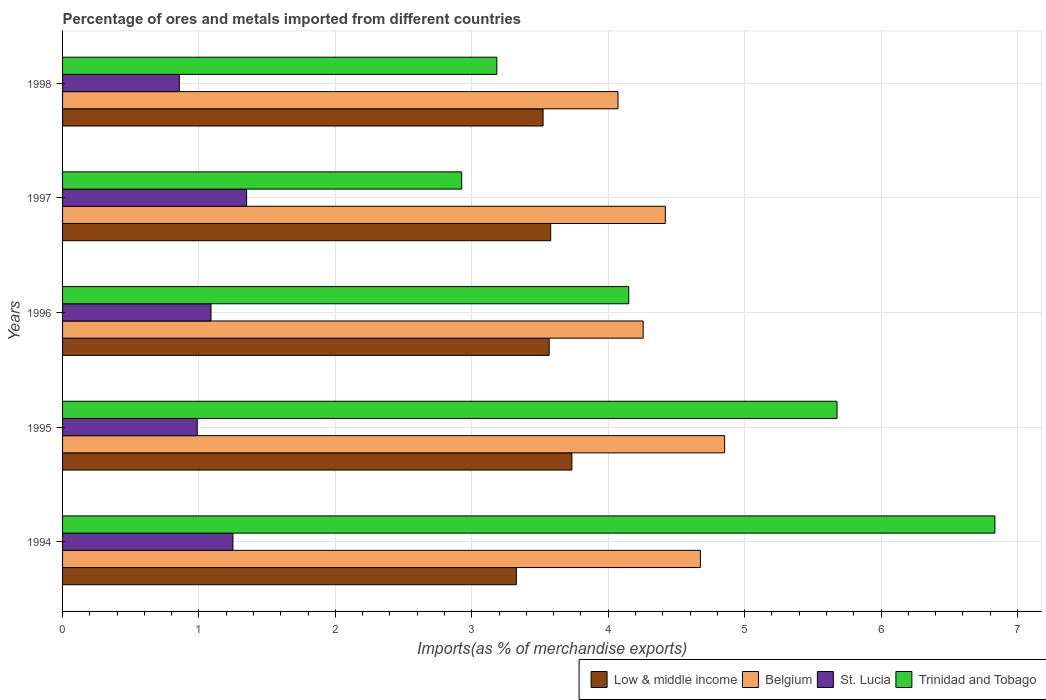How many groups of bars are there?
Your answer should be compact. 5. Are the number of bars per tick equal to the number of legend labels?
Offer a very short reply. Yes. Are the number of bars on each tick of the Y-axis equal?
Provide a succinct answer. Yes. What is the label of the 2nd group of bars from the top?
Your response must be concise. 1997. What is the percentage of imports to different countries in Trinidad and Tobago in 1996?
Your answer should be very brief. 4.15. Across all years, what is the maximum percentage of imports to different countries in Belgium?
Your answer should be very brief. 4.85. Across all years, what is the minimum percentage of imports to different countries in St. Lucia?
Your answer should be very brief. 0.86. In which year was the percentage of imports to different countries in Trinidad and Tobago maximum?
Give a very brief answer. 1994. What is the total percentage of imports to different countries in Belgium in the graph?
Keep it short and to the point. 22.28. What is the difference between the percentage of imports to different countries in Trinidad and Tobago in 1996 and that in 1997?
Your answer should be very brief. 1.22. What is the difference between the percentage of imports to different countries in Trinidad and Tobago in 1994 and the percentage of imports to different countries in St. Lucia in 1998?
Offer a very short reply. 5.98. What is the average percentage of imports to different countries in St. Lucia per year?
Your response must be concise. 1.11. In the year 1996, what is the difference between the percentage of imports to different countries in Low & middle income and percentage of imports to different countries in Belgium?
Your answer should be very brief. -0.69. In how many years, is the percentage of imports to different countries in St. Lucia greater than 1.8 %?
Make the answer very short. 0. What is the ratio of the percentage of imports to different countries in Low & middle income in 1996 to that in 1998?
Make the answer very short. 1.01. Is the percentage of imports to different countries in Belgium in 1996 less than that in 1998?
Give a very brief answer. No. Is the difference between the percentage of imports to different countries in Low & middle income in 1994 and 1996 greater than the difference between the percentage of imports to different countries in Belgium in 1994 and 1996?
Ensure brevity in your answer.  No. What is the difference between the highest and the second highest percentage of imports to different countries in Trinidad and Tobago?
Offer a terse response. 1.16. What is the difference between the highest and the lowest percentage of imports to different countries in Trinidad and Tobago?
Your response must be concise. 3.91. Is it the case that in every year, the sum of the percentage of imports to different countries in Trinidad and Tobago and percentage of imports to different countries in Low & middle income is greater than the sum of percentage of imports to different countries in Belgium and percentage of imports to different countries in St. Lucia?
Make the answer very short. No. What does the 4th bar from the top in 1997 represents?
Provide a short and direct response. Low & middle income. What does the 2nd bar from the bottom in 1995 represents?
Your answer should be compact. Belgium. How many bars are there?
Your response must be concise. 20. How many years are there in the graph?
Offer a terse response. 5. What is the difference between two consecutive major ticks on the X-axis?
Your response must be concise. 1. Are the values on the major ticks of X-axis written in scientific E-notation?
Give a very brief answer. No. Does the graph contain grids?
Offer a very short reply. Yes. Where does the legend appear in the graph?
Your answer should be very brief. Bottom right. How are the legend labels stacked?
Your response must be concise. Horizontal. What is the title of the graph?
Provide a succinct answer. Percentage of ores and metals imported from different countries. What is the label or title of the X-axis?
Provide a short and direct response. Imports(as % of merchandise exports). What is the Imports(as % of merchandise exports) in Low & middle income in 1994?
Ensure brevity in your answer.  3.33. What is the Imports(as % of merchandise exports) in Belgium in 1994?
Your response must be concise. 4.68. What is the Imports(as % of merchandise exports) in St. Lucia in 1994?
Provide a succinct answer. 1.25. What is the Imports(as % of merchandise exports) of Trinidad and Tobago in 1994?
Provide a succinct answer. 6.83. What is the Imports(as % of merchandise exports) in Low & middle income in 1995?
Give a very brief answer. 3.73. What is the Imports(as % of merchandise exports) of Belgium in 1995?
Keep it short and to the point. 4.85. What is the Imports(as % of merchandise exports) of St. Lucia in 1995?
Ensure brevity in your answer.  0.99. What is the Imports(as % of merchandise exports) in Trinidad and Tobago in 1995?
Provide a succinct answer. 5.68. What is the Imports(as % of merchandise exports) in Low & middle income in 1996?
Make the answer very short. 3.57. What is the Imports(as % of merchandise exports) of Belgium in 1996?
Provide a short and direct response. 4.26. What is the Imports(as % of merchandise exports) in St. Lucia in 1996?
Provide a short and direct response. 1.09. What is the Imports(as % of merchandise exports) of Trinidad and Tobago in 1996?
Give a very brief answer. 4.15. What is the Imports(as % of merchandise exports) in Low & middle income in 1997?
Provide a short and direct response. 3.58. What is the Imports(as % of merchandise exports) in Belgium in 1997?
Provide a short and direct response. 4.42. What is the Imports(as % of merchandise exports) of St. Lucia in 1997?
Your answer should be compact. 1.35. What is the Imports(as % of merchandise exports) in Trinidad and Tobago in 1997?
Provide a succinct answer. 2.93. What is the Imports(as % of merchandise exports) of Low & middle income in 1998?
Offer a very short reply. 3.52. What is the Imports(as % of merchandise exports) in Belgium in 1998?
Keep it short and to the point. 4.07. What is the Imports(as % of merchandise exports) of St. Lucia in 1998?
Your answer should be very brief. 0.86. What is the Imports(as % of merchandise exports) in Trinidad and Tobago in 1998?
Provide a succinct answer. 3.18. Across all years, what is the maximum Imports(as % of merchandise exports) of Low & middle income?
Your answer should be compact. 3.73. Across all years, what is the maximum Imports(as % of merchandise exports) in Belgium?
Provide a short and direct response. 4.85. Across all years, what is the maximum Imports(as % of merchandise exports) of St. Lucia?
Keep it short and to the point. 1.35. Across all years, what is the maximum Imports(as % of merchandise exports) in Trinidad and Tobago?
Offer a very short reply. 6.83. Across all years, what is the minimum Imports(as % of merchandise exports) of Low & middle income?
Make the answer very short. 3.33. Across all years, what is the minimum Imports(as % of merchandise exports) in Belgium?
Your response must be concise. 4.07. Across all years, what is the minimum Imports(as % of merchandise exports) in St. Lucia?
Give a very brief answer. 0.86. Across all years, what is the minimum Imports(as % of merchandise exports) of Trinidad and Tobago?
Your answer should be very brief. 2.93. What is the total Imports(as % of merchandise exports) of Low & middle income in the graph?
Offer a terse response. 17.73. What is the total Imports(as % of merchandise exports) in Belgium in the graph?
Provide a succinct answer. 22.28. What is the total Imports(as % of merchandise exports) in St. Lucia in the graph?
Give a very brief answer. 5.53. What is the total Imports(as % of merchandise exports) in Trinidad and Tobago in the graph?
Provide a succinct answer. 22.77. What is the difference between the Imports(as % of merchandise exports) of Low & middle income in 1994 and that in 1995?
Provide a succinct answer. -0.41. What is the difference between the Imports(as % of merchandise exports) in Belgium in 1994 and that in 1995?
Ensure brevity in your answer.  -0.18. What is the difference between the Imports(as % of merchandise exports) in St. Lucia in 1994 and that in 1995?
Your answer should be compact. 0.26. What is the difference between the Imports(as % of merchandise exports) of Trinidad and Tobago in 1994 and that in 1995?
Your answer should be compact. 1.16. What is the difference between the Imports(as % of merchandise exports) of Low & middle income in 1994 and that in 1996?
Your answer should be compact. -0.24. What is the difference between the Imports(as % of merchandise exports) of Belgium in 1994 and that in 1996?
Your response must be concise. 0.42. What is the difference between the Imports(as % of merchandise exports) of St. Lucia in 1994 and that in 1996?
Make the answer very short. 0.16. What is the difference between the Imports(as % of merchandise exports) of Trinidad and Tobago in 1994 and that in 1996?
Provide a succinct answer. 2.68. What is the difference between the Imports(as % of merchandise exports) of Low & middle income in 1994 and that in 1997?
Make the answer very short. -0.25. What is the difference between the Imports(as % of merchandise exports) in Belgium in 1994 and that in 1997?
Offer a terse response. 0.26. What is the difference between the Imports(as % of merchandise exports) in St. Lucia in 1994 and that in 1997?
Ensure brevity in your answer.  -0.1. What is the difference between the Imports(as % of merchandise exports) in Trinidad and Tobago in 1994 and that in 1997?
Make the answer very short. 3.91. What is the difference between the Imports(as % of merchandise exports) in Low & middle income in 1994 and that in 1998?
Your answer should be compact. -0.2. What is the difference between the Imports(as % of merchandise exports) of Belgium in 1994 and that in 1998?
Offer a terse response. 0.6. What is the difference between the Imports(as % of merchandise exports) in St. Lucia in 1994 and that in 1998?
Offer a very short reply. 0.39. What is the difference between the Imports(as % of merchandise exports) of Trinidad and Tobago in 1994 and that in 1998?
Your answer should be very brief. 3.65. What is the difference between the Imports(as % of merchandise exports) of Low & middle income in 1995 and that in 1996?
Offer a terse response. 0.17. What is the difference between the Imports(as % of merchandise exports) in Belgium in 1995 and that in 1996?
Provide a succinct answer. 0.6. What is the difference between the Imports(as % of merchandise exports) in St. Lucia in 1995 and that in 1996?
Give a very brief answer. -0.1. What is the difference between the Imports(as % of merchandise exports) of Trinidad and Tobago in 1995 and that in 1996?
Provide a succinct answer. 1.53. What is the difference between the Imports(as % of merchandise exports) of Low & middle income in 1995 and that in 1997?
Your answer should be compact. 0.16. What is the difference between the Imports(as % of merchandise exports) of Belgium in 1995 and that in 1997?
Provide a succinct answer. 0.43. What is the difference between the Imports(as % of merchandise exports) of St. Lucia in 1995 and that in 1997?
Make the answer very short. -0.36. What is the difference between the Imports(as % of merchandise exports) in Trinidad and Tobago in 1995 and that in 1997?
Ensure brevity in your answer.  2.75. What is the difference between the Imports(as % of merchandise exports) in Low & middle income in 1995 and that in 1998?
Provide a succinct answer. 0.21. What is the difference between the Imports(as % of merchandise exports) in Belgium in 1995 and that in 1998?
Offer a very short reply. 0.78. What is the difference between the Imports(as % of merchandise exports) of St. Lucia in 1995 and that in 1998?
Make the answer very short. 0.13. What is the difference between the Imports(as % of merchandise exports) of Trinidad and Tobago in 1995 and that in 1998?
Offer a very short reply. 2.49. What is the difference between the Imports(as % of merchandise exports) in Low & middle income in 1996 and that in 1997?
Keep it short and to the point. -0.01. What is the difference between the Imports(as % of merchandise exports) of Belgium in 1996 and that in 1997?
Offer a terse response. -0.16. What is the difference between the Imports(as % of merchandise exports) in St. Lucia in 1996 and that in 1997?
Your response must be concise. -0.26. What is the difference between the Imports(as % of merchandise exports) in Trinidad and Tobago in 1996 and that in 1997?
Give a very brief answer. 1.22. What is the difference between the Imports(as % of merchandise exports) of Low & middle income in 1996 and that in 1998?
Make the answer very short. 0.04. What is the difference between the Imports(as % of merchandise exports) of Belgium in 1996 and that in 1998?
Make the answer very short. 0.18. What is the difference between the Imports(as % of merchandise exports) in St. Lucia in 1996 and that in 1998?
Give a very brief answer. 0.23. What is the difference between the Imports(as % of merchandise exports) in Low & middle income in 1997 and that in 1998?
Provide a succinct answer. 0.06. What is the difference between the Imports(as % of merchandise exports) of Belgium in 1997 and that in 1998?
Give a very brief answer. 0.35. What is the difference between the Imports(as % of merchandise exports) of St. Lucia in 1997 and that in 1998?
Offer a terse response. 0.49. What is the difference between the Imports(as % of merchandise exports) in Trinidad and Tobago in 1997 and that in 1998?
Give a very brief answer. -0.26. What is the difference between the Imports(as % of merchandise exports) of Low & middle income in 1994 and the Imports(as % of merchandise exports) of Belgium in 1995?
Provide a short and direct response. -1.53. What is the difference between the Imports(as % of merchandise exports) in Low & middle income in 1994 and the Imports(as % of merchandise exports) in St. Lucia in 1995?
Give a very brief answer. 2.34. What is the difference between the Imports(as % of merchandise exports) in Low & middle income in 1994 and the Imports(as % of merchandise exports) in Trinidad and Tobago in 1995?
Make the answer very short. -2.35. What is the difference between the Imports(as % of merchandise exports) of Belgium in 1994 and the Imports(as % of merchandise exports) of St. Lucia in 1995?
Provide a succinct answer. 3.69. What is the difference between the Imports(as % of merchandise exports) of Belgium in 1994 and the Imports(as % of merchandise exports) of Trinidad and Tobago in 1995?
Provide a short and direct response. -1. What is the difference between the Imports(as % of merchandise exports) of St. Lucia in 1994 and the Imports(as % of merchandise exports) of Trinidad and Tobago in 1995?
Your answer should be very brief. -4.43. What is the difference between the Imports(as % of merchandise exports) in Low & middle income in 1994 and the Imports(as % of merchandise exports) in Belgium in 1996?
Ensure brevity in your answer.  -0.93. What is the difference between the Imports(as % of merchandise exports) of Low & middle income in 1994 and the Imports(as % of merchandise exports) of St. Lucia in 1996?
Offer a terse response. 2.24. What is the difference between the Imports(as % of merchandise exports) in Low & middle income in 1994 and the Imports(as % of merchandise exports) in Trinidad and Tobago in 1996?
Offer a terse response. -0.82. What is the difference between the Imports(as % of merchandise exports) in Belgium in 1994 and the Imports(as % of merchandise exports) in St. Lucia in 1996?
Make the answer very short. 3.59. What is the difference between the Imports(as % of merchandise exports) of Belgium in 1994 and the Imports(as % of merchandise exports) of Trinidad and Tobago in 1996?
Keep it short and to the point. 0.53. What is the difference between the Imports(as % of merchandise exports) in St. Lucia in 1994 and the Imports(as % of merchandise exports) in Trinidad and Tobago in 1996?
Offer a very short reply. -2.9. What is the difference between the Imports(as % of merchandise exports) in Low & middle income in 1994 and the Imports(as % of merchandise exports) in Belgium in 1997?
Your answer should be very brief. -1.09. What is the difference between the Imports(as % of merchandise exports) of Low & middle income in 1994 and the Imports(as % of merchandise exports) of St. Lucia in 1997?
Your response must be concise. 1.98. What is the difference between the Imports(as % of merchandise exports) in Low & middle income in 1994 and the Imports(as % of merchandise exports) in Trinidad and Tobago in 1997?
Make the answer very short. 0.4. What is the difference between the Imports(as % of merchandise exports) in Belgium in 1994 and the Imports(as % of merchandise exports) in St. Lucia in 1997?
Your answer should be compact. 3.33. What is the difference between the Imports(as % of merchandise exports) in Belgium in 1994 and the Imports(as % of merchandise exports) in Trinidad and Tobago in 1997?
Offer a very short reply. 1.75. What is the difference between the Imports(as % of merchandise exports) in St. Lucia in 1994 and the Imports(as % of merchandise exports) in Trinidad and Tobago in 1997?
Give a very brief answer. -1.68. What is the difference between the Imports(as % of merchandise exports) of Low & middle income in 1994 and the Imports(as % of merchandise exports) of Belgium in 1998?
Make the answer very short. -0.75. What is the difference between the Imports(as % of merchandise exports) in Low & middle income in 1994 and the Imports(as % of merchandise exports) in St. Lucia in 1998?
Your answer should be compact. 2.47. What is the difference between the Imports(as % of merchandise exports) in Low & middle income in 1994 and the Imports(as % of merchandise exports) in Trinidad and Tobago in 1998?
Offer a very short reply. 0.14. What is the difference between the Imports(as % of merchandise exports) in Belgium in 1994 and the Imports(as % of merchandise exports) in St. Lucia in 1998?
Your answer should be very brief. 3.82. What is the difference between the Imports(as % of merchandise exports) of Belgium in 1994 and the Imports(as % of merchandise exports) of Trinidad and Tobago in 1998?
Your response must be concise. 1.49. What is the difference between the Imports(as % of merchandise exports) in St. Lucia in 1994 and the Imports(as % of merchandise exports) in Trinidad and Tobago in 1998?
Give a very brief answer. -1.93. What is the difference between the Imports(as % of merchandise exports) of Low & middle income in 1995 and the Imports(as % of merchandise exports) of Belgium in 1996?
Offer a very short reply. -0.52. What is the difference between the Imports(as % of merchandise exports) in Low & middle income in 1995 and the Imports(as % of merchandise exports) in St. Lucia in 1996?
Keep it short and to the point. 2.65. What is the difference between the Imports(as % of merchandise exports) in Low & middle income in 1995 and the Imports(as % of merchandise exports) in Trinidad and Tobago in 1996?
Your answer should be compact. -0.42. What is the difference between the Imports(as % of merchandise exports) of Belgium in 1995 and the Imports(as % of merchandise exports) of St. Lucia in 1996?
Offer a terse response. 3.77. What is the difference between the Imports(as % of merchandise exports) of Belgium in 1995 and the Imports(as % of merchandise exports) of Trinidad and Tobago in 1996?
Ensure brevity in your answer.  0.7. What is the difference between the Imports(as % of merchandise exports) in St. Lucia in 1995 and the Imports(as % of merchandise exports) in Trinidad and Tobago in 1996?
Your answer should be compact. -3.16. What is the difference between the Imports(as % of merchandise exports) of Low & middle income in 1995 and the Imports(as % of merchandise exports) of Belgium in 1997?
Provide a short and direct response. -0.68. What is the difference between the Imports(as % of merchandise exports) of Low & middle income in 1995 and the Imports(as % of merchandise exports) of St. Lucia in 1997?
Offer a terse response. 2.38. What is the difference between the Imports(as % of merchandise exports) of Low & middle income in 1995 and the Imports(as % of merchandise exports) of Trinidad and Tobago in 1997?
Offer a very short reply. 0.81. What is the difference between the Imports(as % of merchandise exports) in Belgium in 1995 and the Imports(as % of merchandise exports) in St. Lucia in 1997?
Your answer should be compact. 3.5. What is the difference between the Imports(as % of merchandise exports) of Belgium in 1995 and the Imports(as % of merchandise exports) of Trinidad and Tobago in 1997?
Make the answer very short. 1.93. What is the difference between the Imports(as % of merchandise exports) of St. Lucia in 1995 and the Imports(as % of merchandise exports) of Trinidad and Tobago in 1997?
Offer a very short reply. -1.94. What is the difference between the Imports(as % of merchandise exports) in Low & middle income in 1995 and the Imports(as % of merchandise exports) in Belgium in 1998?
Provide a succinct answer. -0.34. What is the difference between the Imports(as % of merchandise exports) in Low & middle income in 1995 and the Imports(as % of merchandise exports) in St. Lucia in 1998?
Your response must be concise. 2.88. What is the difference between the Imports(as % of merchandise exports) of Low & middle income in 1995 and the Imports(as % of merchandise exports) of Trinidad and Tobago in 1998?
Keep it short and to the point. 0.55. What is the difference between the Imports(as % of merchandise exports) of Belgium in 1995 and the Imports(as % of merchandise exports) of St. Lucia in 1998?
Your answer should be very brief. 4. What is the difference between the Imports(as % of merchandise exports) of Belgium in 1995 and the Imports(as % of merchandise exports) of Trinidad and Tobago in 1998?
Ensure brevity in your answer.  1.67. What is the difference between the Imports(as % of merchandise exports) in St. Lucia in 1995 and the Imports(as % of merchandise exports) in Trinidad and Tobago in 1998?
Keep it short and to the point. -2.2. What is the difference between the Imports(as % of merchandise exports) of Low & middle income in 1996 and the Imports(as % of merchandise exports) of Belgium in 1997?
Provide a succinct answer. -0.85. What is the difference between the Imports(as % of merchandise exports) of Low & middle income in 1996 and the Imports(as % of merchandise exports) of St. Lucia in 1997?
Ensure brevity in your answer.  2.22. What is the difference between the Imports(as % of merchandise exports) in Low & middle income in 1996 and the Imports(as % of merchandise exports) in Trinidad and Tobago in 1997?
Make the answer very short. 0.64. What is the difference between the Imports(as % of merchandise exports) of Belgium in 1996 and the Imports(as % of merchandise exports) of St. Lucia in 1997?
Offer a terse response. 2.91. What is the difference between the Imports(as % of merchandise exports) of Belgium in 1996 and the Imports(as % of merchandise exports) of Trinidad and Tobago in 1997?
Make the answer very short. 1.33. What is the difference between the Imports(as % of merchandise exports) of St. Lucia in 1996 and the Imports(as % of merchandise exports) of Trinidad and Tobago in 1997?
Provide a short and direct response. -1.84. What is the difference between the Imports(as % of merchandise exports) of Low & middle income in 1996 and the Imports(as % of merchandise exports) of Belgium in 1998?
Your response must be concise. -0.5. What is the difference between the Imports(as % of merchandise exports) of Low & middle income in 1996 and the Imports(as % of merchandise exports) of St. Lucia in 1998?
Your answer should be compact. 2.71. What is the difference between the Imports(as % of merchandise exports) of Low & middle income in 1996 and the Imports(as % of merchandise exports) of Trinidad and Tobago in 1998?
Give a very brief answer. 0.38. What is the difference between the Imports(as % of merchandise exports) in Belgium in 1996 and the Imports(as % of merchandise exports) in St. Lucia in 1998?
Provide a short and direct response. 3.4. What is the difference between the Imports(as % of merchandise exports) in Belgium in 1996 and the Imports(as % of merchandise exports) in Trinidad and Tobago in 1998?
Make the answer very short. 1.07. What is the difference between the Imports(as % of merchandise exports) of St. Lucia in 1996 and the Imports(as % of merchandise exports) of Trinidad and Tobago in 1998?
Ensure brevity in your answer.  -2.1. What is the difference between the Imports(as % of merchandise exports) of Low & middle income in 1997 and the Imports(as % of merchandise exports) of Belgium in 1998?
Provide a short and direct response. -0.49. What is the difference between the Imports(as % of merchandise exports) in Low & middle income in 1997 and the Imports(as % of merchandise exports) in St. Lucia in 1998?
Keep it short and to the point. 2.72. What is the difference between the Imports(as % of merchandise exports) of Low & middle income in 1997 and the Imports(as % of merchandise exports) of Trinidad and Tobago in 1998?
Keep it short and to the point. 0.39. What is the difference between the Imports(as % of merchandise exports) of Belgium in 1997 and the Imports(as % of merchandise exports) of St. Lucia in 1998?
Provide a succinct answer. 3.56. What is the difference between the Imports(as % of merchandise exports) in Belgium in 1997 and the Imports(as % of merchandise exports) in Trinidad and Tobago in 1998?
Offer a terse response. 1.24. What is the difference between the Imports(as % of merchandise exports) in St. Lucia in 1997 and the Imports(as % of merchandise exports) in Trinidad and Tobago in 1998?
Provide a short and direct response. -1.83. What is the average Imports(as % of merchandise exports) in Low & middle income per year?
Offer a very short reply. 3.55. What is the average Imports(as % of merchandise exports) in Belgium per year?
Your answer should be compact. 4.46. What is the average Imports(as % of merchandise exports) in St. Lucia per year?
Provide a short and direct response. 1.11. What is the average Imports(as % of merchandise exports) of Trinidad and Tobago per year?
Offer a very short reply. 4.55. In the year 1994, what is the difference between the Imports(as % of merchandise exports) in Low & middle income and Imports(as % of merchandise exports) in Belgium?
Your answer should be very brief. -1.35. In the year 1994, what is the difference between the Imports(as % of merchandise exports) in Low & middle income and Imports(as % of merchandise exports) in St. Lucia?
Offer a very short reply. 2.08. In the year 1994, what is the difference between the Imports(as % of merchandise exports) in Low & middle income and Imports(as % of merchandise exports) in Trinidad and Tobago?
Offer a terse response. -3.51. In the year 1994, what is the difference between the Imports(as % of merchandise exports) of Belgium and Imports(as % of merchandise exports) of St. Lucia?
Offer a terse response. 3.43. In the year 1994, what is the difference between the Imports(as % of merchandise exports) of Belgium and Imports(as % of merchandise exports) of Trinidad and Tobago?
Offer a terse response. -2.16. In the year 1994, what is the difference between the Imports(as % of merchandise exports) in St. Lucia and Imports(as % of merchandise exports) in Trinidad and Tobago?
Provide a short and direct response. -5.59. In the year 1995, what is the difference between the Imports(as % of merchandise exports) of Low & middle income and Imports(as % of merchandise exports) of Belgium?
Provide a short and direct response. -1.12. In the year 1995, what is the difference between the Imports(as % of merchandise exports) of Low & middle income and Imports(as % of merchandise exports) of St. Lucia?
Provide a short and direct response. 2.75. In the year 1995, what is the difference between the Imports(as % of merchandise exports) in Low & middle income and Imports(as % of merchandise exports) in Trinidad and Tobago?
Give a very brief answer. -1.94. In the year 1995, what is the difference between the Imports(as % of merchandise exports) in Belgium and Imports(as % of merchandise exports) in St. Lucia?
Provide a succinct answer. 3.87. In the year 1995, what is the difference between the Imports(as % of merchandise exports) in Belgium and Imports(as % of merchandise exports) in Trinidad and Tobago?
Offer a very short reply. -0.82. In the year 1995, what is the difference between the Imports(as % of merchandise exports) of St. Lucia and Imports(as % of merchandise exports) of Trinidad and Tobago?
Your response must be concise. -4.69. In the year 1996, what is the difference between the Imports(as % of merchandise exports) of Low & middle income and Imports(as % of merchandise exports) of Belgium?
Provide a short and direct response. -0.69. In the year 1996, what is the difference between the Imports(as % of merchandise exports) of Low & middle income and Imports(as % of merchandise exports) of St. Lucia?
Provide a short and direct response. 2.48. In the year 1996, what is the difference between the Imports(as % of merchandise exports) in Low & middle income and Imports(as % of merchandise exports) in Trinidad and Tobago?
Ensure brevity in your answer.  -0.58. In the year 1996, what is the difference between the Imports(as % of merchandise exports) of Belgium and Imports(as % of merchandise exports) of St. Lucia?
Your response must be concise. 3.17. In the year 1996, what is the difference between the Imports(as % of merchandise exports) of Belgium and Imports(as % of merchandise exports) of Trinidad and Tobago?
Your response must be concise. 0.11. In the year 1996, what is the difference between the Imports(as % of merchandise exports) in St. Lucia and Imports(as % of merchandise exports) in Trinidad and Tobago?
Your answer should be very brief. -3.06. In the year 1997, what is the difference between the Imports(as % of merchandise exports) in Low & middle income and Imports(as % of merchandise exports) in Belgium?
Keep it short and to the point. -0.84. In the year 1997, what is the difference between the Imports(as % of merchandise exports) of Low & middle income and Imports(as % of merchandise exports) of St. Lucia?
Provide a succinct answer. 2.23. In the year 1997, what is the difference between the Imports(as % of merchandise exports) of Low & middle income and Imports(as % of merchandise exports) of Trinidad and Tobago?
Your response must be concise. 0.65. In the year 1997, what is the difference between the Imports(as % of merchandise exports) of Belgium and Imports(as % of merchandise exports) of St. Lucia?
Keep it short and to the point. 3.07. In the year 1997, what is the difference between the Imports(as % of merchandise exports) of Belgium and Imports(as % of merchandise exports) of Trinidad and Tobago?
Your response must be concise. 1.49. In the year 1997, what is the difference between the Imports(as % of merchandise exports) of St. Lucia and Imports(as % of merchandise exports) of Trinidad and Tobago?
Your answer should be compact. -1.58. In the year 1998, what is the difference between the Imports(as % of merchandise exports) in Low & middle income and Imports(as % of merchandise exports) in Belgium?
Your response must be concise. -0.55. In the year 1998, what is the difference between the Imports(as % of merchandise exports) of Low & middle income and Imports(as % of merchandise exports) of St. Lucia?
Give a very brief answer. 2.67. In the year 1998, what is the difference between the Imports(as % of merchandise exports) in Low & middle income and Imports(as % of merchandise exports) in Trinidad and Tobago?
Your answer should be compact. 0.34. In the year 1998, what is the difference between the Imports(as % of merchandise exports) of Belgium and Imports(as % of merchandise exports) of St. Lucia?
Provide a short and direct response. 3.22. In the year 1998, what is the difference between the Imports(as % of merchandise exports) in Belgium and Imports(as % of merchandise exports) in Trinidad and Tobago?
Your answer should be very brief. 0.89. In the year 1998, what is the difference between the Imports(as % of merchandise exports) of St. Lucia and Imports(as % of merchandise exports) of Trinidad and Tobago?
Provide a succinct answer. -2.33. What is the ratio of the Imports(as % of merchandise exports) of Low & middle income in 1994 to that in 1995?
Keep it short and to the point. 0.89. What is the ratio of the Imports(as % of merchandise exports) in Belgium in 1994 to that in 1995?
Ensure brevity in your answer.  0.96. What is the ratio of the Imports(as % of merchandise exports) in St. Lucia in 1994 to that in 1995?
Keep it short and to the point. 1.27. What is the ratio of the Imports(as % of merchandise exports) of Trinidad and Tobago in 1994 to that in 1995?
Offer a terse response. 1.2. What is the ratio of the Imports(as % of merchandise exports) in Low & middle income in 1994 to that in 1996?
Your answer should be compact. 0.93. What is the ratio of the Imports(as % of merchandise exports) in Belgium in 1994 to that in 1996?
Offer a very short reply. 1.1. What is the ratio of the Imports(as % of merchandise exports) of St. Lucia in 1994 to that in 1996?
Provide a succinct answer. 1.15. What is the ratio of the Imports(as % of merchandise exports) in Trinidad and Tobago in 1994 to that in 1996?
Your answer should be very brief. 1.65. What is the ratio of the Imports(as % of merchandise exports) of Low & middle income in 1994 to that in 1997?
Your response must be concise. 0.93. What is the ratio of the Imports(as % of merchandise exports) in Belgium in 1994 to that in 1997?
Your answer should be very brief. 1.06. What is the ratio of the Imports(as % of merchandise exports) of St. Lucia in 1994 to that in 1997?
Make the answer very short. 0.93. What is the ratio of the Imports(as % of merchandise exports) in Trinidad and Tobago in 1994 to that in 1997?
Your response must be concise. 2.34. What is the ratio of the Imports(as % of merchandise exports) of Belgium in 1994 to that in 1998?
Your answer should be very brief. 1.15. What is the ratio of the Imports(as % of merchandise exports) of St. Lucia in 1994 to that in 1998?
Give a very brief answer. 1.46. What is the ratio of the Imports(as % of merchandise exports) in Trinidad and Tobago in 1994 to that in 1998?
Provide a succinct answer. 2.15. What is the ratio of the Imports(as % of merchandise exports) in Low & middle income in 1995 to that in 1996?
Provide a succinct answer. 1.05. What is the ratio of the Imports(as % of merchandise exports) in Belgium in 1995 to that in 1996?
Provide a short and direct response. 1.14. What is the ratio of the Imports(as % of merchandise exports) in St. Lucia in 1995 to that in 1996?
Give a very brief answer. 0.91. What is the ratio of the Imports(as % of merchandise exports) of Trinidad and Tobago in 1995 to that in 1996?
Your response must be concise. 1.37. What is the ratio of the Imports(as % of merchandise exports) in Low & middle income in 1995 to that in 1997?
Your answer should be compact. 1.04. What is the ratio of the Imports(as % of merchandise exports) in Belgium in 1995 to that in 1997?
Give a very brief answer. 1.1. What is the ratio of the Imports(as % of merchandise exports) in St. Lucia in 1995 to that in 1997?
Provide a succinct answer. 0.73. What is the ratio of the Imports(as % of merchandise exports) of Trinidad and Tobago in 1995 to that in 1997?
Keep it short and to the point. 1.94. What is the ratio of the Imports(as % of merchandise exports) in Low & middle income in 1995 to that in 1998?
Keep it short and to the point. 1.06. What is the ratio of the Imports(as % of merchandise exports) of Belgium in 1995 to that in 1998?
Provide a succinct answer. 1.19. What is the ratio of the Imports(as % of merchandise exports) in St. Lucia in 1995 to that in 1998?
Offer a very short reply. 1.15. What is the ratio of the Imports(as % of merchandise exports) of Trinidad and Tobago in 1995 to that in 1998?
Your answer should be compact. 1.78. What is the ratio of the Imports(as % of merchandise exports) of Low & middle income in 1996 to that in 1997?
Offer a terse response. 1. What is the ratio of the Imports(as % of merchandise exports) in Belgium in 1996 to that in 1997?
Your response must be concise. 0.96. What is the ratio of the Imports(as % of merchandise exports) in St. Lucia in 1996 to that in 1997?
Your answer should be compact. 0.81. What is the ratio of the Imports(as % of merchandise exports) of Trinidad and Tobago in 1996 to that in 1997?
Ensure brevity in your answer.  1.42. What is the ratio of the Imports(as % of merchandise exports) of Low & middle income in 1996 to that in 1998?
Provide a short and direct response. 1.01. What is the ratio of the Imports(as % of merchandise exports) in Belgium in 1996 to that in 1998?
Give a very brief answer. 1.05. What is the ratio of the Imports(as % of merchandise exports) in St. Lucia in 1996 to that in 1998?
Offer a very short reply. 1.27. What is the ratio of the Imports(as % of merchandise exports) of Trinidad and Tobago in 1996 to that in 1998?
Keep it short and to the point. 1.3. What is the ratio of the Imports(as % of merchandise exports) of Low & middle income in 1997 to that in 1998?
Your answer should be compact. 1.02. What is the ratio of the Imports(as % of merchandise exports) in Belgium in 1997 to that in 1998?
Keep it short and to the point. 1.09. What is the ratio of the Imports(as % of merchandise exports) in St. Lucia in 1997 to that in 1998?
Offer a terse response. 1.58. What is the ratio of the Imports(as % of merchandise exports) in Trinidad and Tobago in 1997 to that in 1998?
Your answer should be very brief. 0.92. What is the difference between the highest and the second highest Imports(as % of merchandise exports) of Low & middle income?
Offer a terse response. 0.16. What is the difference between the highest and the second highest Imports(as % of merchandise exports) of Belgium?
Offer a terse response. 0.18. What is the difference between the highest and the second highest Imports(as % of merchandise exports) of St. Lucia?
Give a very brief answer. 0.1. What is the difference between the highest and the second highest Imports(as % of merchandise exports) in Trinidad and Tobago?
Your answer should be compact. 1.16. What is the difference between the highest and the lowest Imports(as % of merchandise exports) of Low & middle income?
Offer a very short reply. 0.41. What is the difference between the highest and the lowest Imports(as % of merchandise exports) of Belgium?
Your response must be concise. 0.78. What is the difference between the highest and the lowest Imports(as % of merchandise exports) of St. Lucia?
Your answer should be very brief. 0.49. What is the difference between the highest and the lowest Imports(as % of merchandise exports) of Trinidad and Tobago?
Offer a terse response. 3.91. 